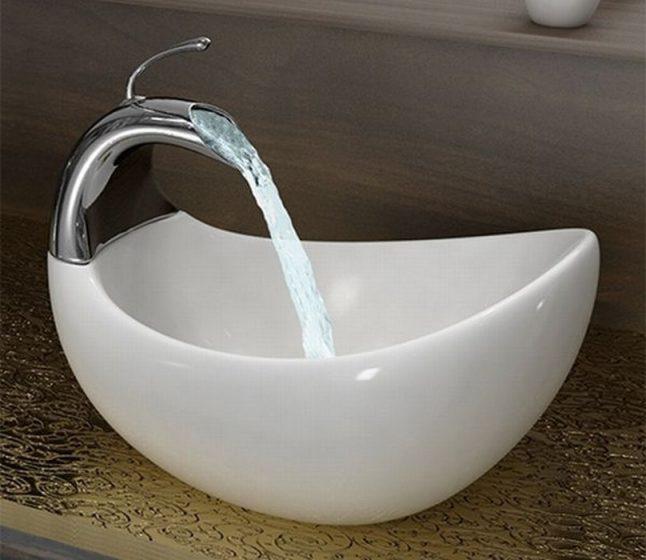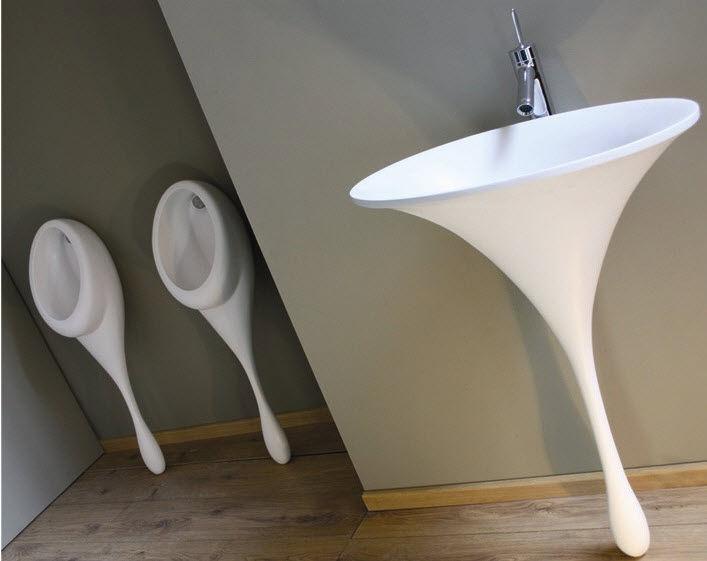The first image is the image on the left, the second image is the image on the right. Analyze the images presented: Is the assertion "The combined images include a white pedestal sink with a narrow, drop-like base, and a gooseneck spout over a rounded bowl-type sink." valid? Answer yes or no. Yes. 